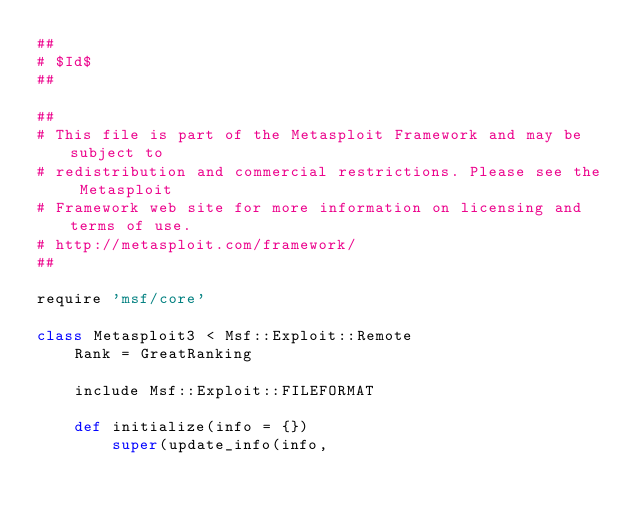Convert code to text. <code><loc_0><loc_0><loc_500><loc_500><_Ruby_>##
# $Id$
##

##
# This file is part of the Metasploit Framework and may be subject to
# redistribution and commercial restrictions. Please see the Metasploit
# Framework web site for more information on licensing and terms of use.
# http://metasploit.com/framework/
##

require 'msf/core'

class Metasploit3 < Msf::Exploit::Remote
	Rank = GreatRanking

	include Msf::Exploit::FILEFORMAT

	def initialize(info = {})
		super(update_info(info,</code> 